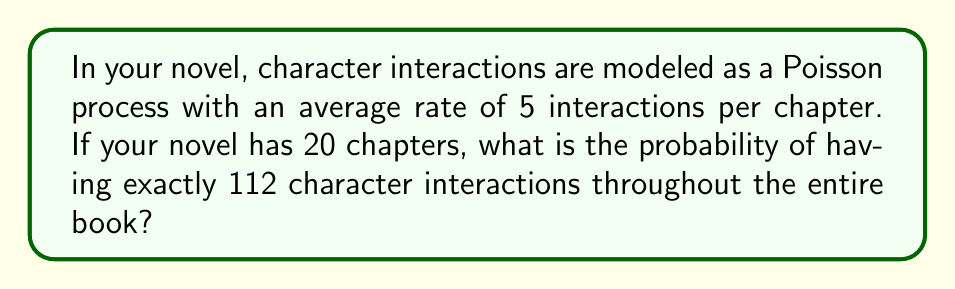Show me your answer to this math problem. Let's approach this step-by-step:

1) First, we need to identify the parameters of our Poisson process:
   - The rate (λ) per chapter is 5
   - The number of chapters (n) is 20

2) For the entire book, we need to calculate the total rate:
   $$\lambda_{total} = \lambda * n = 5 * 20 = 100$$

3) Now, we want to find the probability of exactly 112 interactions (k = 112) given a rate of 100 for the entire book.

4) The Poisson probability mass function is:
   $$P(X = k) = \frac{e^{-\lambda} \lambda^k}{k!}$$

5) Substituting our values:
   $$P(X = 112) = \frac{e^{-100} 100^{112}}{112!}$$

6) This can be calculated using a calculator or computer program:
   $$P(X = 112) \approx 0.0399$$

7) To interpret this in the context of your novel: There's about a 3.99% chance of having exactly 112 character interactions in your 20-chapter novel, given an average of 5 interactions per chapter.

This mathematical model could provide insights into the pacing and density of character interactions in your storytelling, potentially influencing how you develop your characters and their relationships throughout the novel.
Answer: 0.0399 